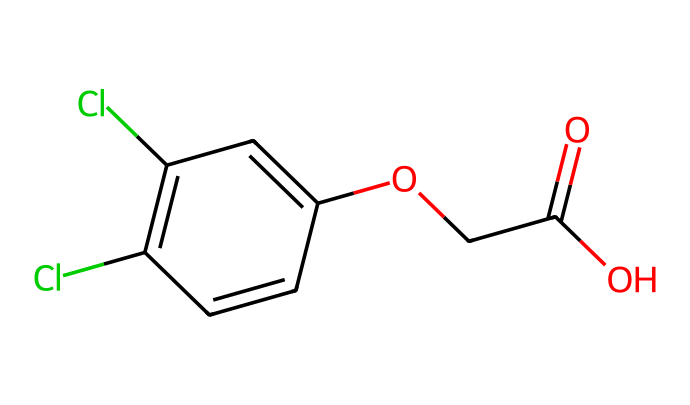What is the molecular formula of 2,4-Dichlorophenoxyacetic acid? By analyzing the SMILES representation, we can identify the components: There are 2 chlorine (Cl) atoms, 12 carbon (C) atoms, 13 hydrogen (H) atoms, and 5 oxygen (O) atoms. We combine these into a molecular formula which reveals the composition.
Answer: C8H6Cl2O3 How many rings are present in the structure of 2,4-D? Inspecting the SMILES representation, the structure includes one benzene ring, which is a cyclic compound. Therefore, we count the ring present in its overall molecular structure.
Answer: 1 What functional group can be identified in 2,4-D's structure? The presence of the -COOH group in the structure indicates the presence of a carboxylic acid. This can be identified from the oxygen atoms associated with it and its molecular arrangement.
Answer: carboxylic acid What is the chlorine atom's position on the aromatic ring? Looking closely at the structure, the chlorine atoms are positioned at the 2 and 4 positions on the aromatic ring, as indicated by the numerical identifiers in the SMILES representation.
Answer: 2 and 4 Does 2,4-D have a phenoxy group? The structure includes a phenoxy group, which consists of a phenol (benzene) connected to an ether (oxygen), contributing to its classification and function as a herbicide.
Answer: yes What is the total number of oxygen atoms in the molecular structure? By evaluating the SMILES representation, there are three distinct oxygen atoms represented in the carboxylic acid and ether functional groups, summing them gives us the total.
Answer: 3 